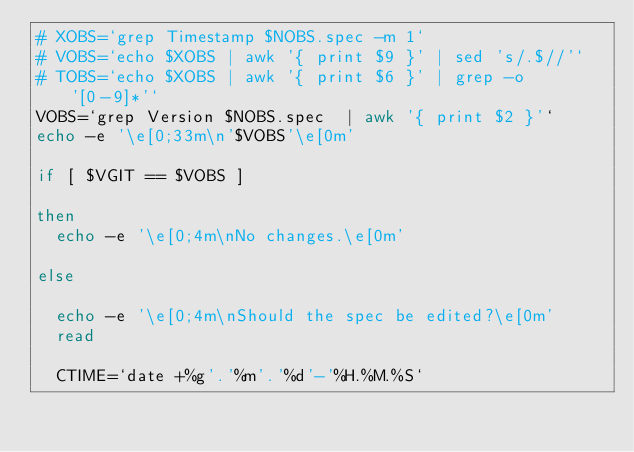Convert code to text. <code><loc_0><loc_0><loc_500><loc_500><_Bash_># XOBS=`grep Timestamp $NOBS.spec -m 1`
# VOBS=`echo $XOBS | awk '{ print $9 }' | sed 's/.$//'`
# TOBS=`echo $XOBS | awk '{ print $6 }' | grep -o '[0-9]*'`
VOBS=`grep Version $NOBS.spec  | awk '{ print $2 }'`
echo -e '\e[0;33m\n'$VOBS'\e[0m'

if [ $VGIT == $VOBS ]

then
  echo -e '\e[0;4m\nNo changes.\e[0m'

else

  echo -e '\e[0;4m\nShould the spec be edited?\e[0m'
  read

  CTIME=`date +%g'.'%m'.'%d'-'%H.%M.%S`</code> 